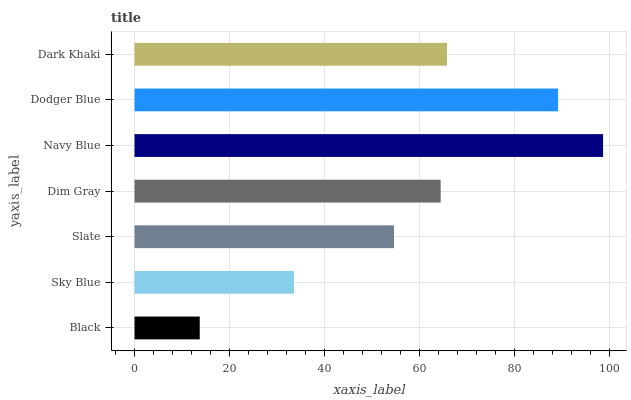Is Black the minimum?
Answer yes or no. Yes. Is Navy Blue the maximum?
Answer yes or no. Yes. Is Sky Blue the minimum?
Answer yes or no. No. Is Sky Blue the maximum?
Answer yes or no. No. Is Sky Blue greater than Black?
Answer yes or no. Yes. Is Black less than Sky Blue?
Answer yes or no. Yes. Is Black greater than Sky Blue?
Answer yes or no. No. Is Sky Blue less than Black?
Answer yes or no. No. Is Dim Gray the high median?
Answer yes or no. Yes. Is Dim Gray the low median?
Answer yes or no. Yes. Is Black the high median?
Answer yes or no. No. Is Dark Khaki the low median?
Answer yes or no. No. 